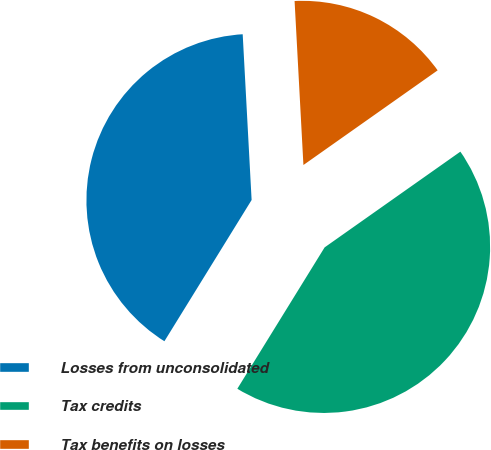<chart> <loc_0><loc_0><loc_500><loc_500><pie_chart><fcel>Losses from unconsolidated<fcel>Tax credits<fcel>Tax benefits on losses<nl><fcel>40.34%<fcel>43.58%<fcel>16.08%<nl></chart> 